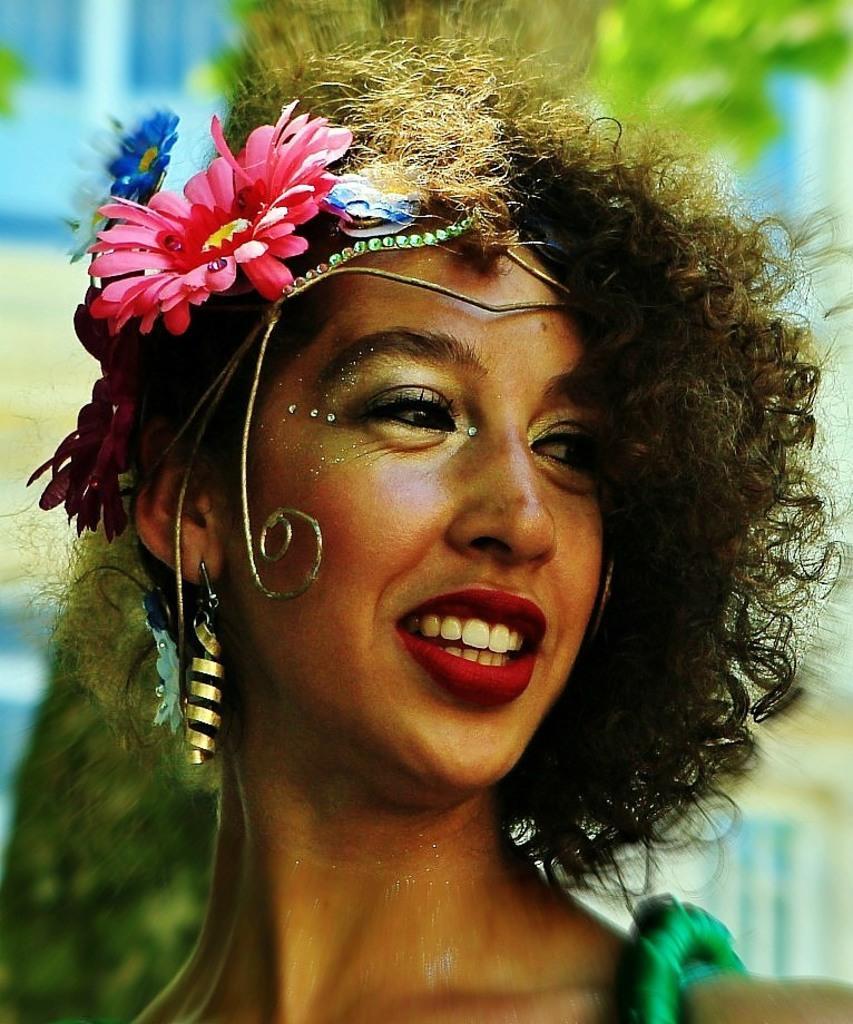Describe this image in one or two sentences. In this image there is a face of a girl. She is wearing the earrings and a flower wreath. 